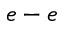Convert formula to latex. <formula><loc_0><loc_0><loc_500><loc_500>e - e</formula> 